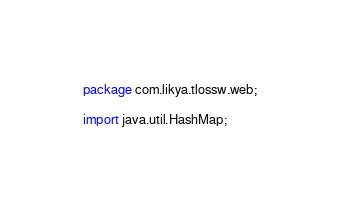Convert code to text. <code><loc_0><loc_0><loc_500><loc_500><_Java_>package com.likya.tlossw.web;

import java.util.HashMap;</code> 